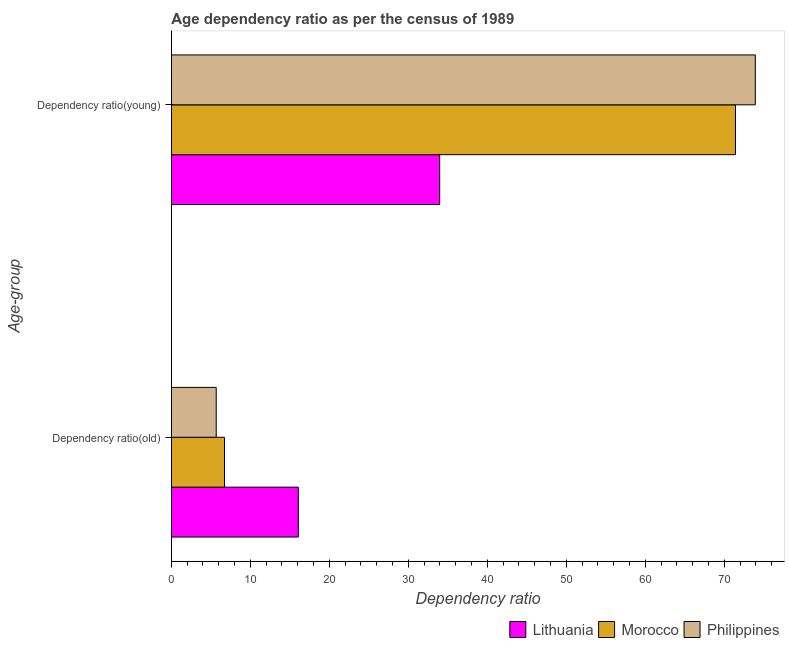How many groups of bars are there?
Make the answer very short. 2. Are the number of bars per tick equal to the number of legend labels?
Give a very brief answer. Yes. Are the number of bars on each tick of the Y-axis equal?
Your answer should be very brief. Yes. How many bars are there on the 1st tick from the top?
Keep it short and to the point. 3. What is the label of the 2nd group of bars from the top?
Offer a very short reply. Dependency ratio(old). What is the age dependency ratio(old) in Lithuania?
Keep it short and to the point. 16.07. Across all countries, what is the maximum age dependency ratio(young)?
Your answer should be compact. 73.92. Across all countries, what is the minimum age dependency ratio(old)?
Ensure brevity in your answer.  5.68. In which country was the age dependency ratio(old) maximum?
Provide a succinct answer. Lithuania. In which country was the age dependency ratio(young) minimum?
Offer a terse response. Lithuania. What is the total age dependency ratio(old) in the graph?
Make the answer very short. 28.47. What is the difference between the age dependency ratio(old) in Philippines and that in Morocco?
Provide a short and direct response. -1.05. What is the difference between the age dependency ratio(old) in Lithuania and the age dependency ratio(young) in Philippines?
Your answer should be compact. -57.85. What is the average age dependency ratio(young) per country?
Keep it short and to the point. 59.76. What is the difference between the age dependency ratio(young) and age dependency ratio(old) in Lithuania?
Make the answer very short. 17.89. In how many countries, is the age dependency ratio(young) greater than 16 ?
Provide a succinct answer. 3. What is the ratio of the age dependency ratio(young) in Philippines to that in Morocco?
Keep it short and to the point. 1.04. What does the 2nd bar from the top in Dependency ratio(young) represents?
Make the answer very short. Morocco. What does the 2nd bar from the bottom in Dependency ratio(young) represents?
Your answer should be very brief. Morocco. What is the difference between two consecutive major ticks on the X-axis?
Keep it short and to the point. 10. Are the values on the major ticks of X-axis written in scientific E-notation?
Your response must be concise. No. Does the graph contain any zero values?
Make the answer very short. No. Does the graph contain grids?
Keep it short and to the point. No. Where does the legend appear in the graph?
Ensure brevity in your answer.  Bottom right. What is the title of the graph?
Offer a terse response. Age dependency ratio as per the census of 1989. Does "Guyana" appear as one of the legend labels in the graph?
Give a very brief answer. No. What is the label or title of the X-axis?
Give a very brief answer. Dependency ratio. What is the label or title of the Y-axis?
Give a very brief answer. Age-group. What is the Dependency ratio in Lithuania in Dependency ratio(old)?
Offer a very short reply. 16.07. What is the Dependency ratio of Morocco in Dependency ratio(old)?
Provide a short and direct response. 6.72. What is the Dependency ratio of Philippines in Dependency ratio(old)?
Your response must be concise. 5.68. What is the Dependency ratio in Lithuania in Dependency ratio(young)?
Your answer should be compact. 33.97. What is the Dependency ratio in Morocco in Dependency ratio(young)?
Offer a very short reply. 71.41. What is the Dependency ratio in Philippines in Dependency ratio(young)?
Your answer should be very brief. 73.92. Across all Age-group, what is the maximum Dependency ratio of Lithuania?
Provide a short and direct response. 33.97. Across all Age-group, what is the maximum Dependency ratio of Morocco?
Your answer should be compact. 71.41. Across all Age-group, what is the maximum Dependency ratio in Philippines?
Provide a succinct answer. 73.92. Across all Age-group, what is the minimum Dependency ratio in Lithuania?
Offer a very short reply. 16.07. Across all Age-group, what is the minimum Dependency ratio of Morocco?
Give a very brief answer. 6.72. Across all Age-group, what is the minimum Dependency ratio of Philippines?
Your answer should be compact. 5.68. What is the total Dependency ratio in Lithuania in the graph?
Ensure brevity in your answer.  50.04. What is the total Dependency ratio of Morocco in the graph?
Keep it short and to the point. 78.13. What is the total Dependency ratio of Philippines in the graph?
Your answer should be compact. 79.59. What is the difference between the Dependency ratio of Lithuania in Dependency ratio(old) and that in Dependency ratio(young)?
Ensure brevity in your answer.  -17.89. What is the difference between the Dependency ratio in Morocco in Dependency ratio(old) and that in Dependency ratio(young)?
Ensure brevity in your answer.  -64.68. What is the difference between the Dependency ratio in Philippines in Dependency ratio(old) and that in Dependency ratio(young)?
Offer a terse response. -68.24. What is the difference between the Dependency ratio in Lithuania in Dependency ratio(old) and the Dependency ratio in Morocco in Dependency ratio(young)?
Make the answer very short. -55.34. What is the difference between the Dependency ratio in Lithuania in Dependency ratio(old) and the Dependency ratio in Philippines in Dependency ratio(young)?
Offer a terse response. -57.85. What is the difference between the Dependency ratio in Morocco in Dependency ratio(old) and the Dependency ratio in Philippines in Dependency ratio(young)?
Offer a very short reply. -67.19. What is the average Dependency ratio in Lithuania per Age-group?
Ensure brevity in your answer.  25.02. What is the average Dependency ratio of Morocco per Age-group?
Offer a very short reply. 39.07. What is the average Dependency ratio in Philippines per Age-group?
Offer a terse response. 39.8. What is the difference between the Dependency ratio of Lithuania and Dependency ratio of Morocco in Dependency ratio(old)?
Offer a terse response. 9.35. What is the difference between the Dependency ratio of Lithuania and Dependency ratio of Philippines in Dependency ratio(old)?
Keep it short and to the point. 10.39. What is the difference between the Dependency ratio in Morocco and Dependency ratio in Philippines in Dependency ratio(old)?
Provide a short and direct response. 1.05. What is the difference between the Dependency ratio of Lithuania and Dependency ratio of Morocco in Dependency ratio(young)?
Provide a succinct answer. -37.44. What is the difference between the Dependency ratio of Lithuania and Dependency ratio of Philippines in Dependency ratio(young)?
Your answer should be compact. -39.95. What is the difference between the Dependency ratio of Morocco and Dependency ratio of Philippines in Dependency ratio(young)?
Provide a succinct answer. -2.51. What is the ratio of the Dependency ratio of Lithuania in Dependency ratio(old) to that in Dependency ratio(young)?
Offer a very short reply. 0.47. What is the ratio of the Dependency ratio of Morocco in Dependency ratio(old) to that in Dependency ratio(young)?
Make the answer very short. 0.09. What is the ratio of the Dependency ratio in Philippines in Dependency ratio(old) to that in Dependency ratio(young)?
Ensure brevity in your answer.  0.08. What is the difference between the highest and the second highest Dependency ratio in Lithuania?
Your answer should be very brief. 17.89. What is the difference between the highest and the second highest Dependency ratio in Morocco?
Make the answer very short. 64.68. What is the difference between the highest and the second highest Dependency ratio in Philippines?
Make the answer very short. 68.24. What is the difference between the highest and the lowest Dependency ratio of Lithuania?
Your response must be concise. 17.89. What is the difference between the highest and the lowest Dependency ratio of Morocco?
Make the answer very short. 64.68. What is the difference between the highest and the lowest Dependency ratio of Philippines?
Your answer should be very brief. 68.24. 